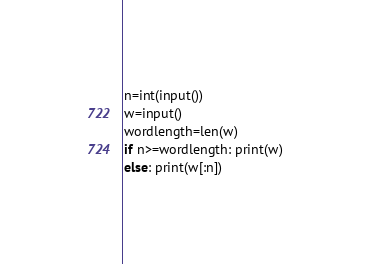Convert code to text. <code><loc_0><loc_0><loc_500><loc_500><_Python_>n=int(input())
w=input()
wordlength=len(w)
if n>=wordlength: print(w)
else: print(w[:n])</code> 